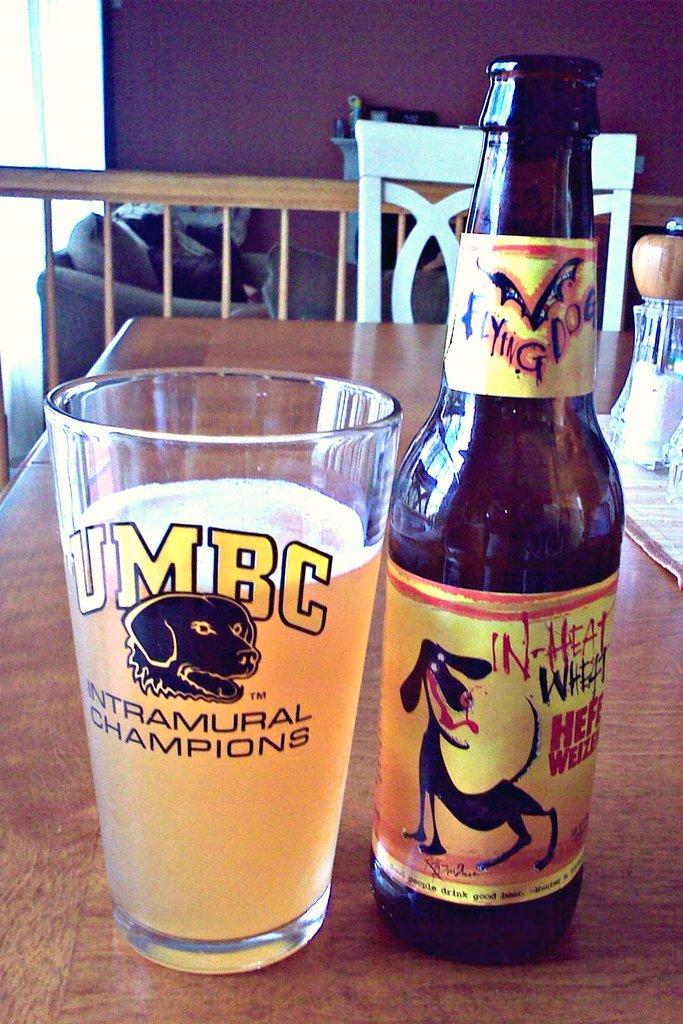What animal is on the bottle?
Make the answer very short. Answering does not require reading text in the image. 